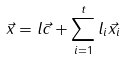<formula> <loc_0><loc_0><loc_500><loc_500>\vec { x } = l \vec { c } + \sum _ { i = 1 } ^ { t } l _ { i } \vec { x } _ { i }</formula> 